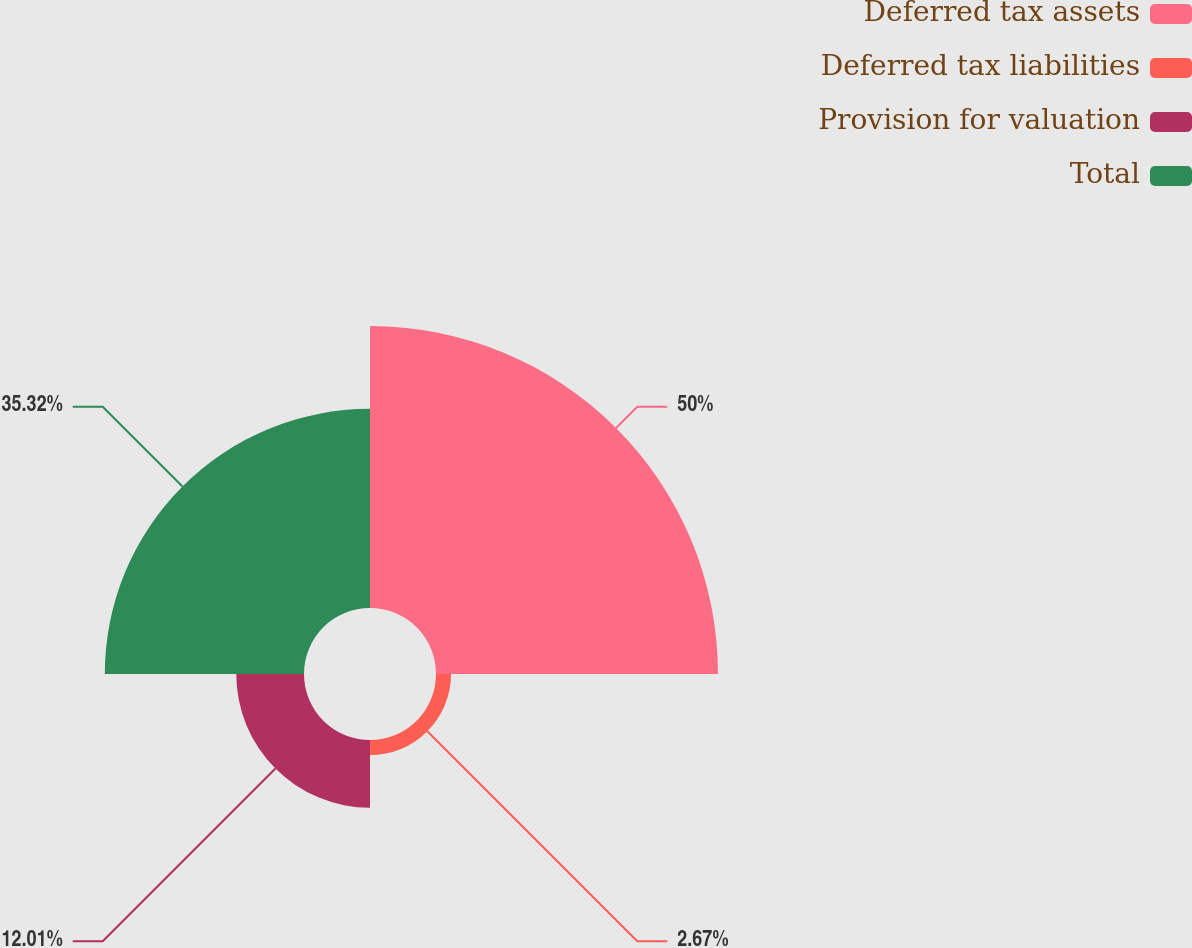Convert chart. <chart><loc_0><loc_0><loc_500><loc_500><pie_chart><fcel>Deferred tax assets<fcel>Deferred tax liabilities<fcel>Provision for valuation<fcel>Total<nl><fcel>50.0%<fcel>2.67%<fcel>12.01%<fcel>35.32%<nl></chart> 